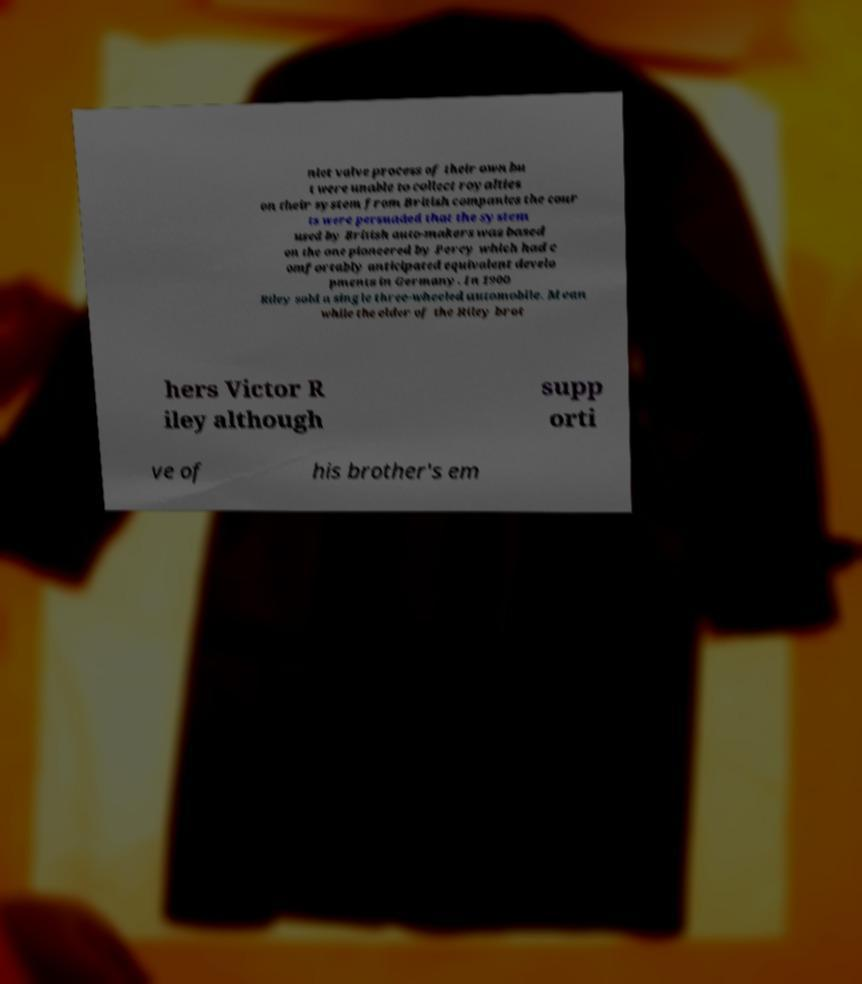Please read and relay the text visible in this image. What does it say? nlet valve process of their own bu t were unable to collect royalties on their system from British companies the cour ts were persuaded that the system used by British auto-makers was based on the one pioneered by Percy which had c omfortably anticipated equivalent develo pments in Germany. In 1900 Riley sold a single three-wheeled automobile. Mean while the elder of the Riley brot hers Victor R iley although supp orti ve of his brother's em 